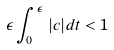<formula> <loc_0><loc_0><loc_500><loc_500>\epsilon \int _ { 0 } ^ { \epsilon } | c | d t < 1</formula> 